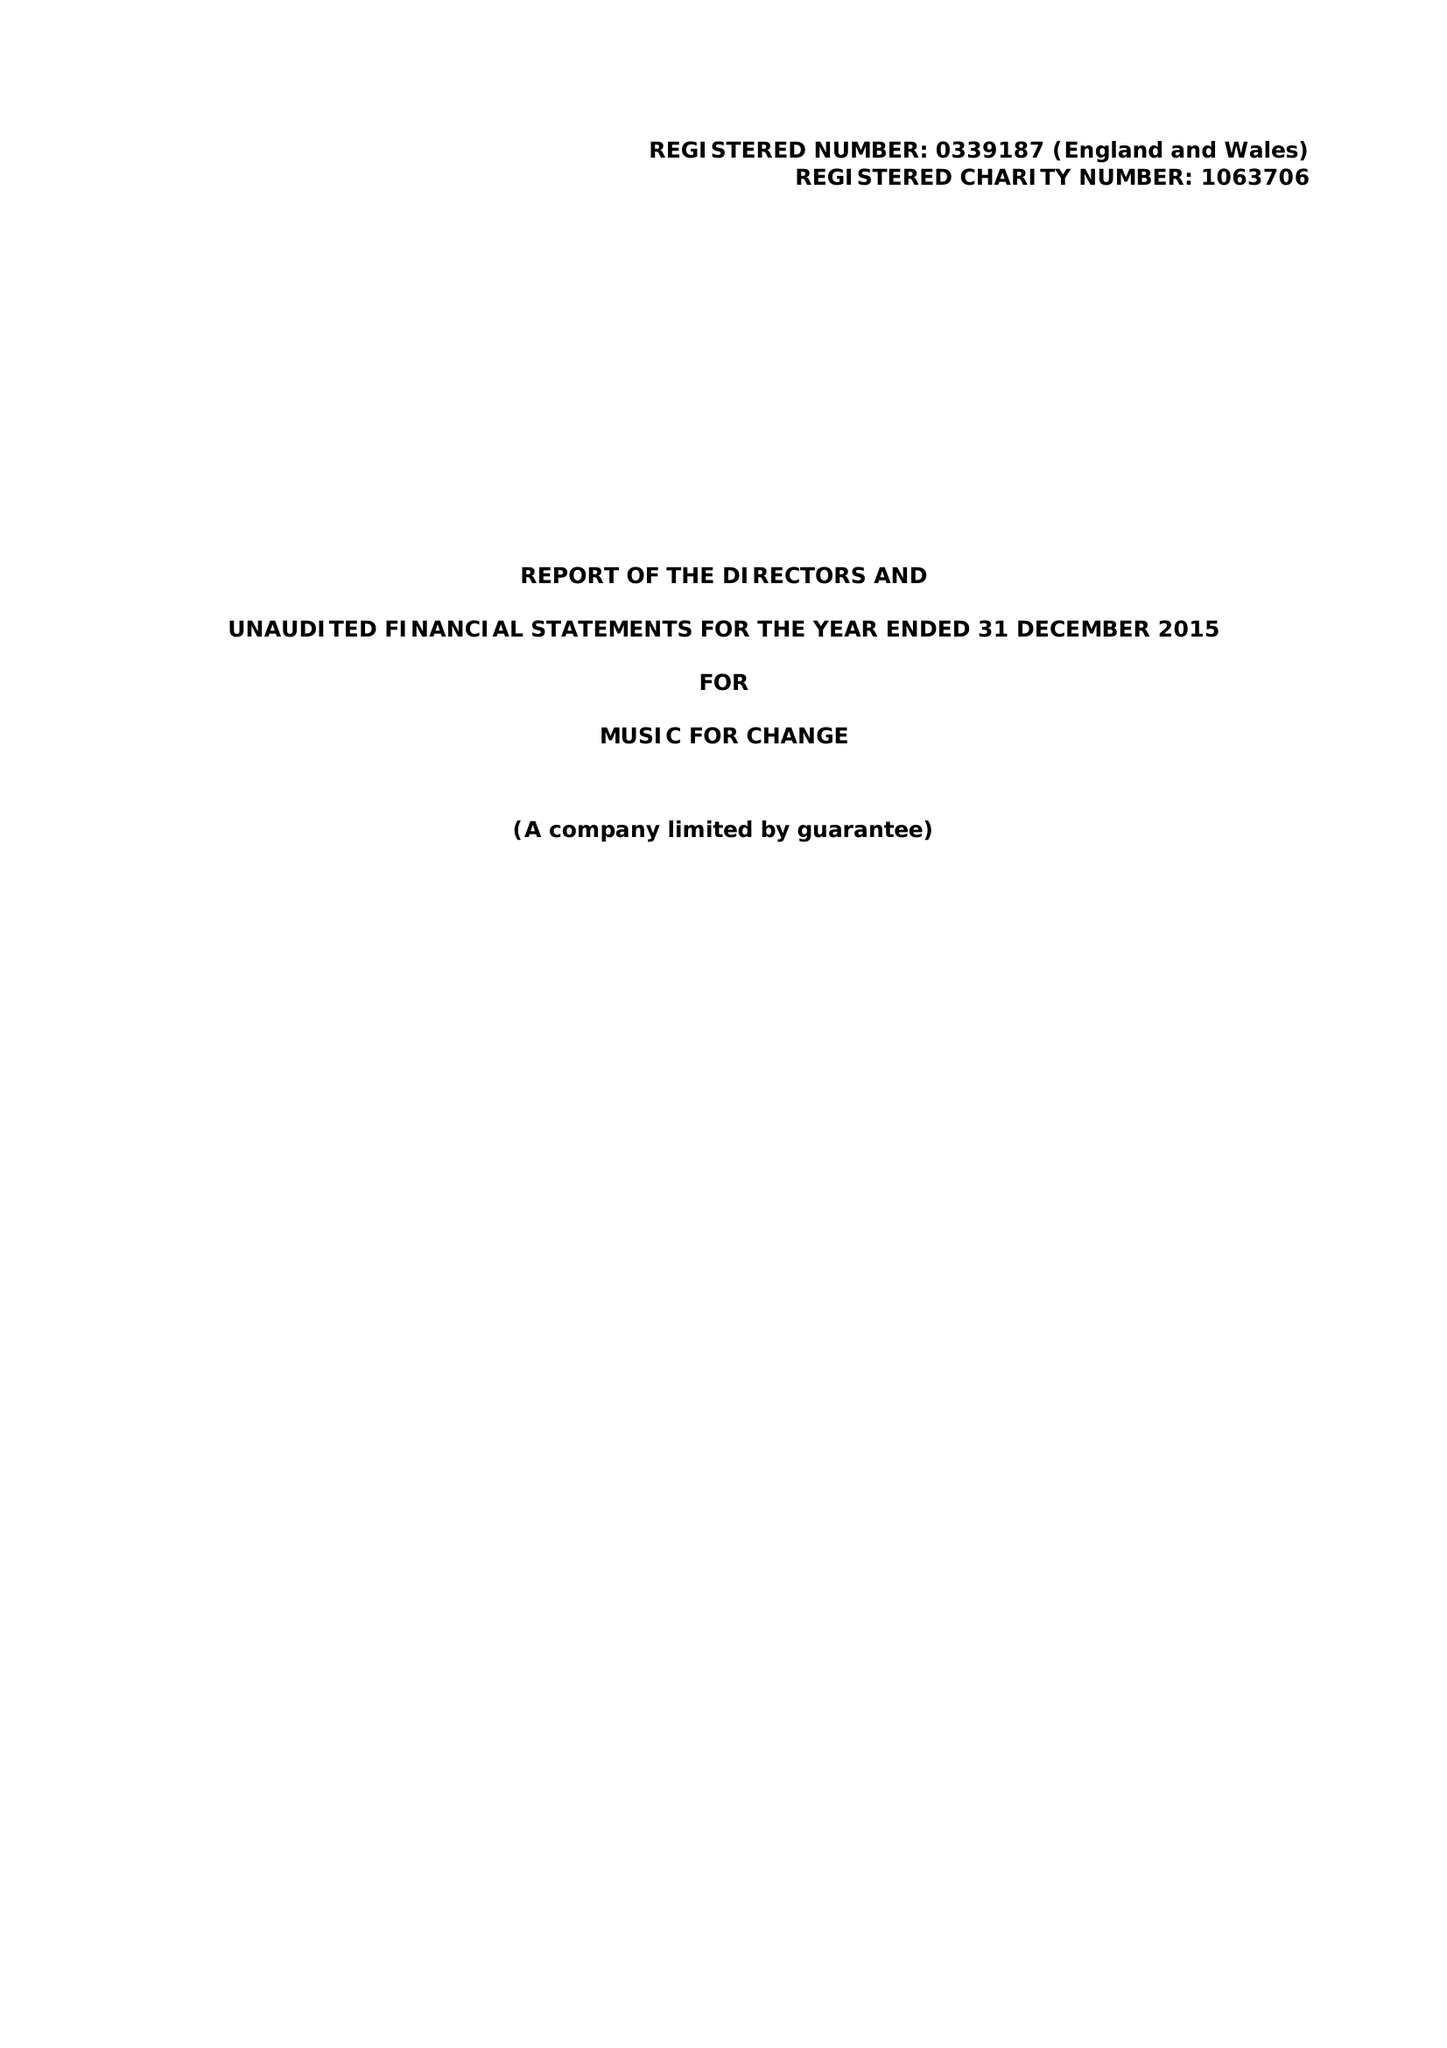What is the value for the income_annually_in_british_pounds?
Answer the question using a single word or phrase. 110000.00 